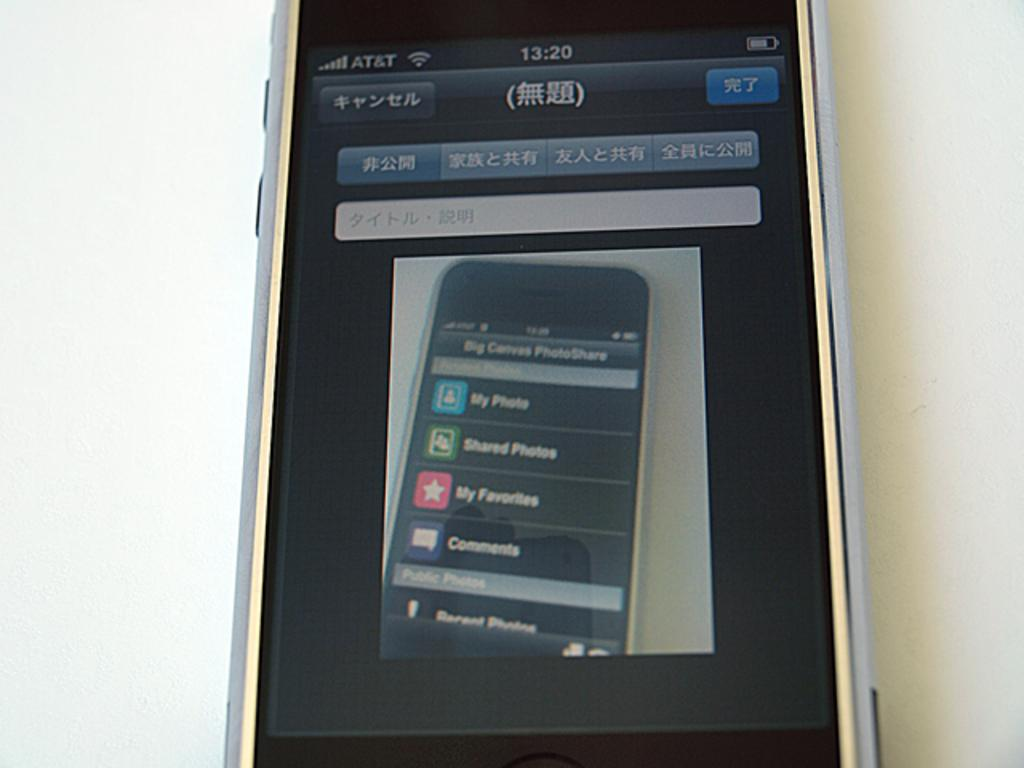<image>
Present a compact description of the photo's key features. An iPhone with the Photoshare screen open showing my photo, shared photos and my favorites. 